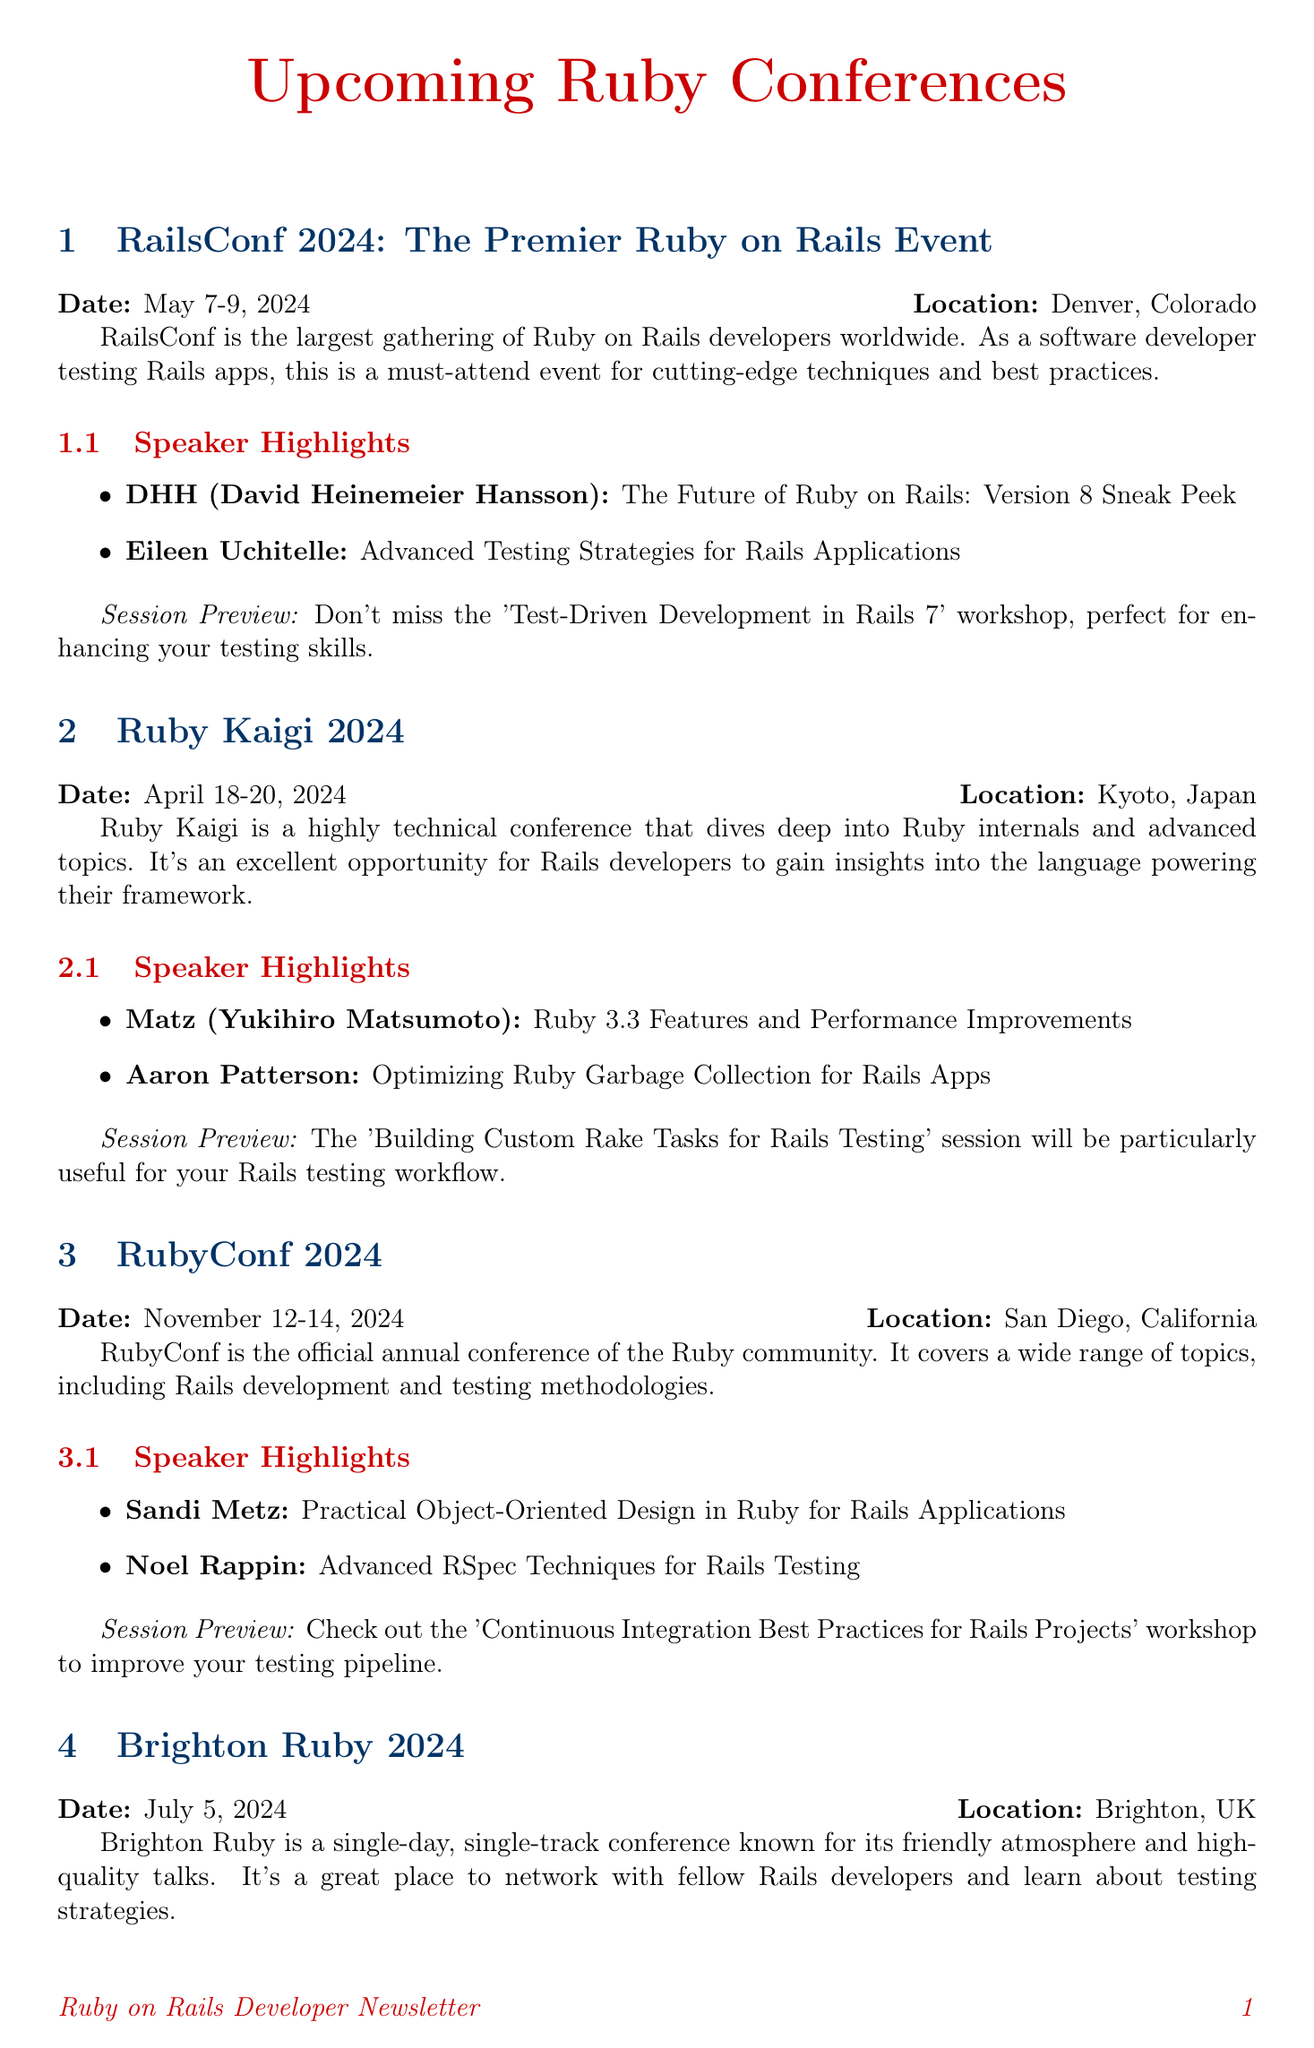What are the dates for RailsConf 2024? The dates for RailsConf 2024 are specifically mentioned in the document as May 7-9, 2024.
Answer: May 7-9, 2024 Who is speaking about Ruby 3.3 features? The document highlights Matz (Yukihiro Matsumoto) as the speaker discussing Ruby 3.3 features.
Answer: Matz (Yukihiro Matsumoto) What location hosts RubyC 2024? The document states that RubyC 2024 will be held in Kyiv, Ukraine.
Answer: Kyiv, Ukraine Which event features a session on Advanced RSpec Techniques? The mention of Advanced RSpec Techniques is linked to RubyConf 2024 in the document.
Answer: RubyConf 2024 How many days is Brighton Ruby 2024? The document specifies that Brighton Ruby is a single-day conference.
Answer: One day What is the primary focus of Ruby Kaigi? Ruby Kaigi is described as a highly technical conference focusing on Ruby internals and advanced topics.
Answer: Ruby internals and advanced topics Who is discussing Metaprogramming in Ruby? The document lists Tom Stuart as the speaker on Metaprogramming in Ruby.
Answer: Tom Stuart What session is recommended for optimizing Rails testing workflows at Ruby Kaigi? The document points out the 'Building Custom Rake Tasks for Rails Testing' session.
Answer: Building Custom Rake Tasks for Rails Testing 